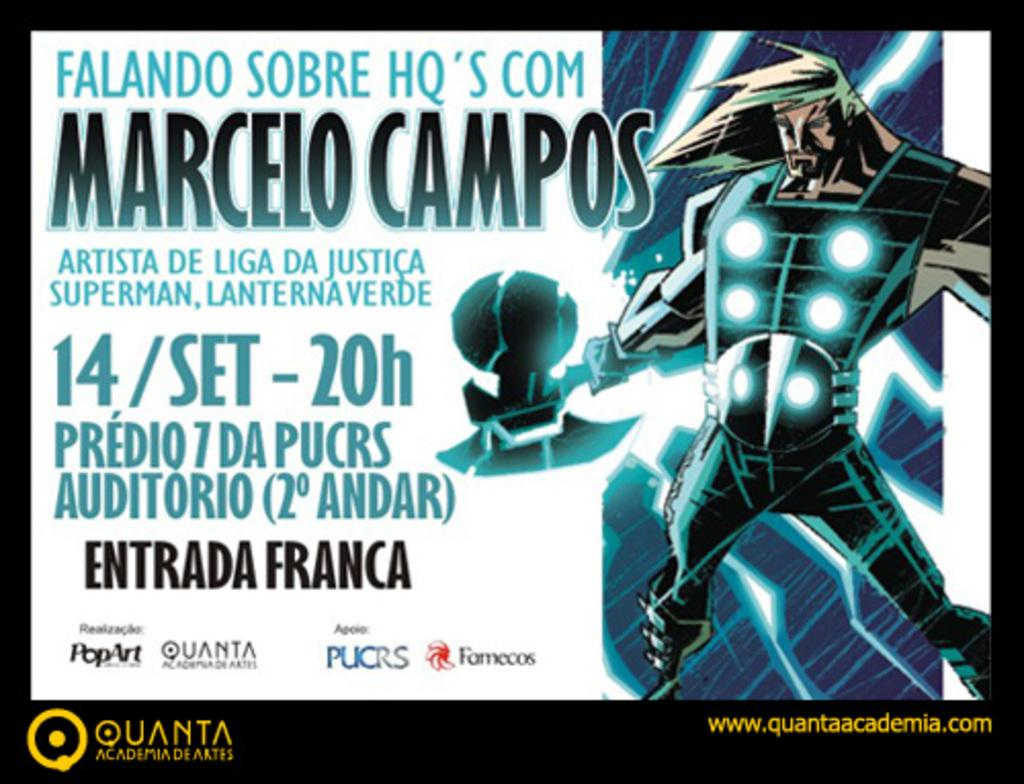<image>
Offer a succinct explanation of the picture presented. A drawing of Thor stands next to an ad for Quanta, displaying the dates for an event. 